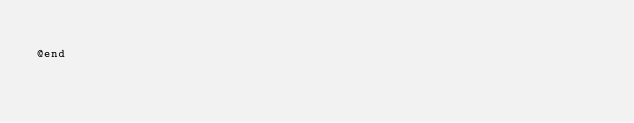<code> <loc_0><loc_0><loc_500><loc_500><_C_>
@end
</code> 